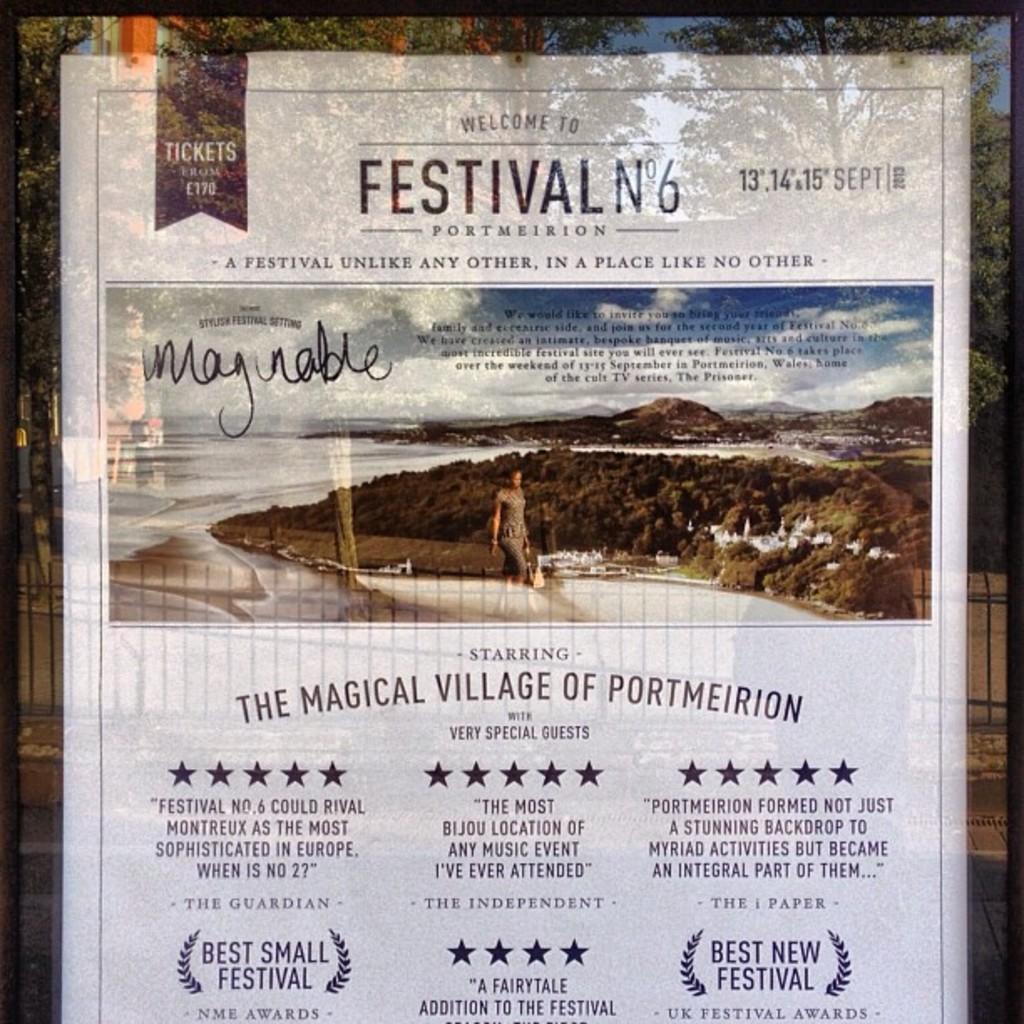What festival is on the flyer?
Keep it short and to the point. No 6. What is being said about this festival according to the bottom right?
Give a very brief answer. Best new festival. 